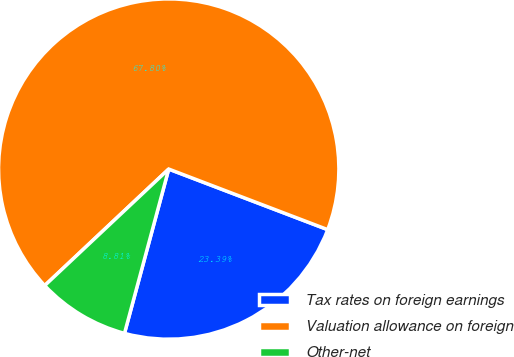Convert chart. <chart><loc_0><loc_0><loc_500><loc_500><pie_chart><fcel>Tax rates on foreign earnings<fcel>Valuation allowance on foreign<fcel>Other-net<nl><fcel>23.39%<fcel>67.8%<fcel>8.81%<nl></chart> 